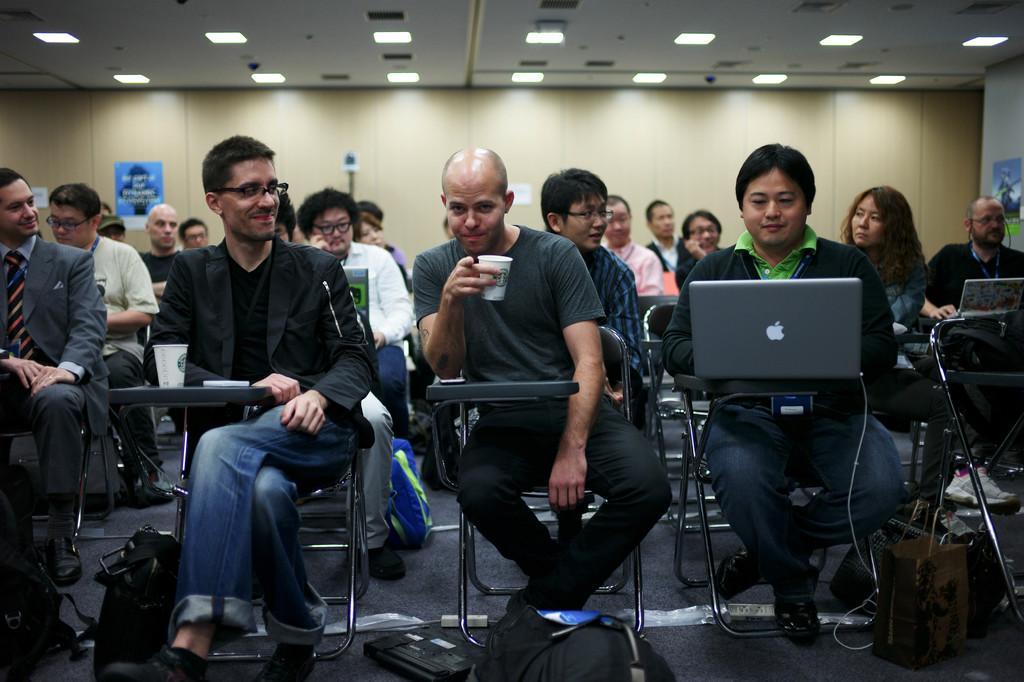Could you give a brief overview of what you see in this image? In this image we can see few persons are sitting on the chairs and there are laptops, glasses and objects on the pads attached to the chairs and we can see a man is holding a cup in his hand. There are bags and objects on the floor. In the background we can see posts on the wall and lights on the ceiling. 